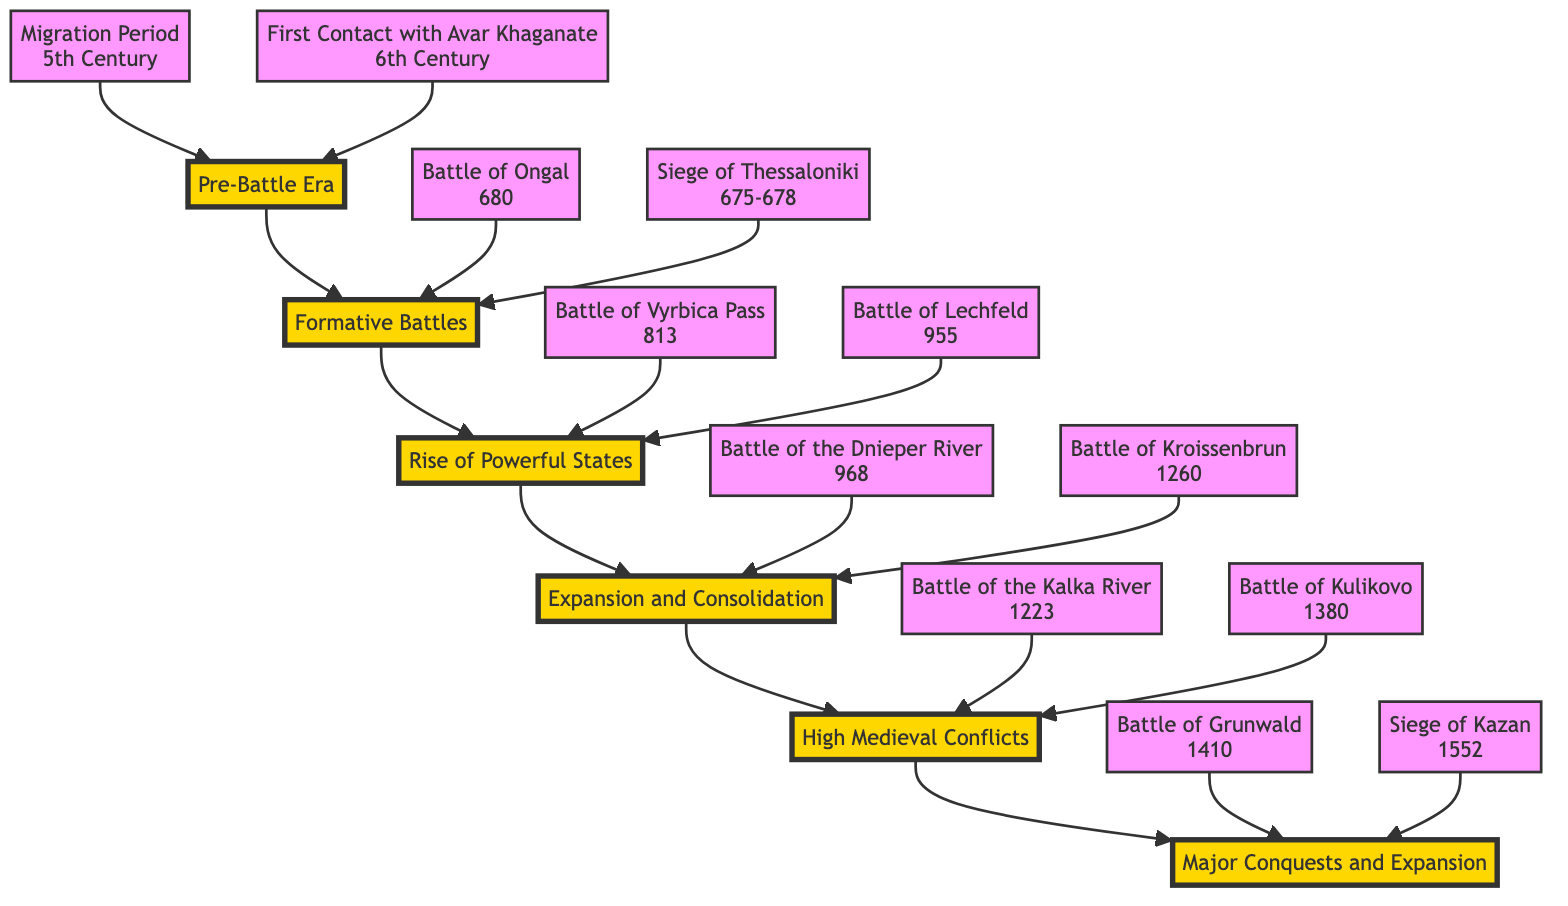What is the earliest era depicted in the diagram? The diagram starts with the "Pre-Battle Era," which represents prehistoric and early medieval times from the 5th to the 7th centuries.
Answer: Pre-Battle Era How many major battle entries are found in the "High Medieval Conflicts" category? In the "High Medieval Conflicts" section, there are two significant battles listed: the Battle of the Kalka River and the Battle of Kulikovo.
Answer: 2 Which battle that led to significant territorial expansion is linked to the Kievan Rus? The "Battle of the Dnieper River," where the Kievan Rus defeated the Khazars, is associated with territorial expansion for the Kievan Rus.
Answer: Battle of the Dnieper River What event led to the rise of the First Bulgarian Empire? The "Battle of Ongal," which took place in 680, is noted as a pivotal event for establishing the First Bulgarian Empire.
Answer: Battle of Ongal What is the direct effect of the Battle of Grunwald? The Battle of Grunwald is significant as it represents a joint Polish-Lithuanian success against the Teutonic Knights, signifying a major shift in power in Eastern Europe.
Answer: Shift in power Which era comes directly after the "Expansion and Consolidation" era? Following the "Expansion and Consolidation" era, the next era depicted in the diagram is the "High Medieval Conflicts."
Answer: High Medieval Conflicts What year marked the defeat of the Kievan Rus at the hands of the Mongol Empire? The "Battle of the Kalka River," which is indicated in the diagram, occurred in the year 1223 and represents the defeat of Kievan Rus by the Mongol Empire.
Answer: 1223 What was the main outcome of the Siege of Kazan? The Siege of Kazan led to the capture of Kazan by the Tsardom of Russia, resulting in the incorporation of Tatar territories into Russia.
Answer: Incorporation of Tatar territories Which battle marks a significant victory for Muscovite forces? The "Battle of Kulikovo," occurring in 1380, is recognized as a major victory for Muscovite forces against the Golden Horde.
Answer: Battle of Kulikovo 